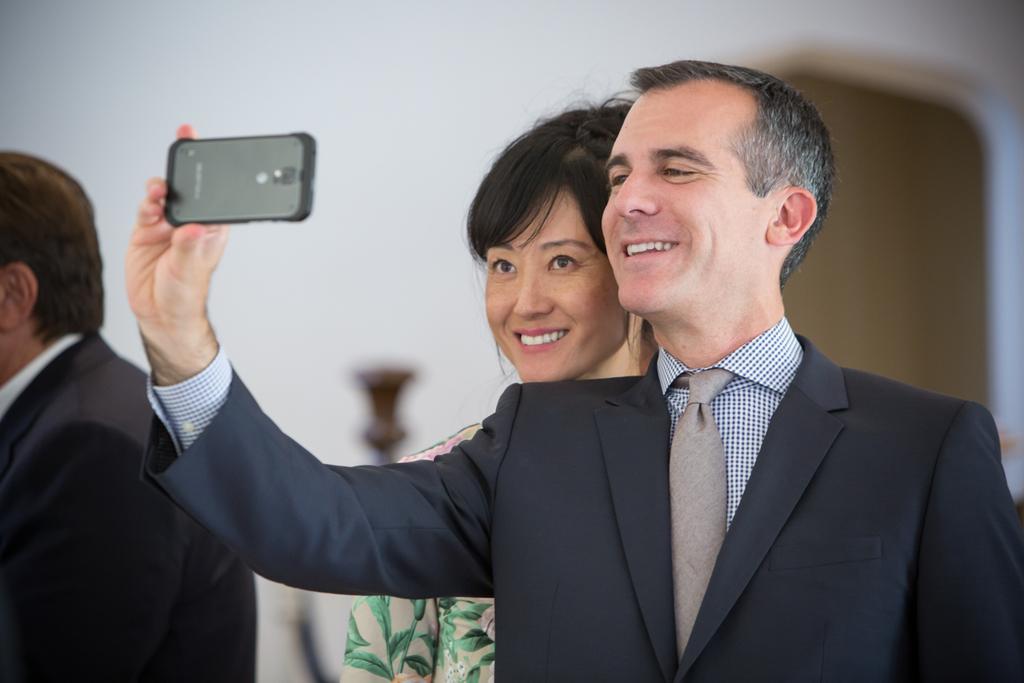Could you give a brief overview of what you see in this image? In this image I can see a person wearing shirt, tie and blazer is standing and holding a cellphone in his hand. I can see a woman wearing white and green colored dress is standing behind him. To the left side of the image I can see another person and in the background I can see the white colored wall and few other objects. 